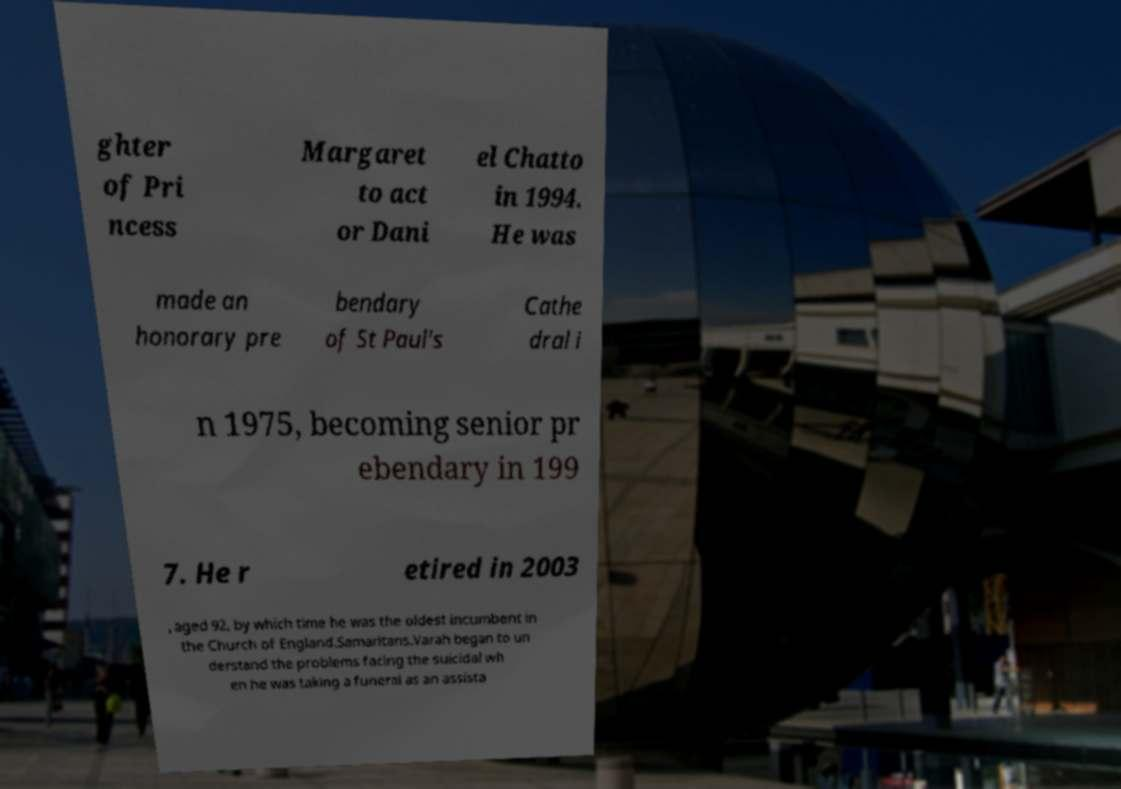Could you extract and type out the text from this image? ghter of Pri ncess Margaret to act or Dani el Chatto in 1994. He was made an honorary pre bendary of St Paul's Cathe dral i n 1975, becoming senior pr ebendary in 199 7. He r etired in 2003 , aged 92, by which time he was the oldest incumbent in the Church of England.Samaritans.Varah began to un derstand the problems facing the suicidal wh en he was taking a funeral as an assista 